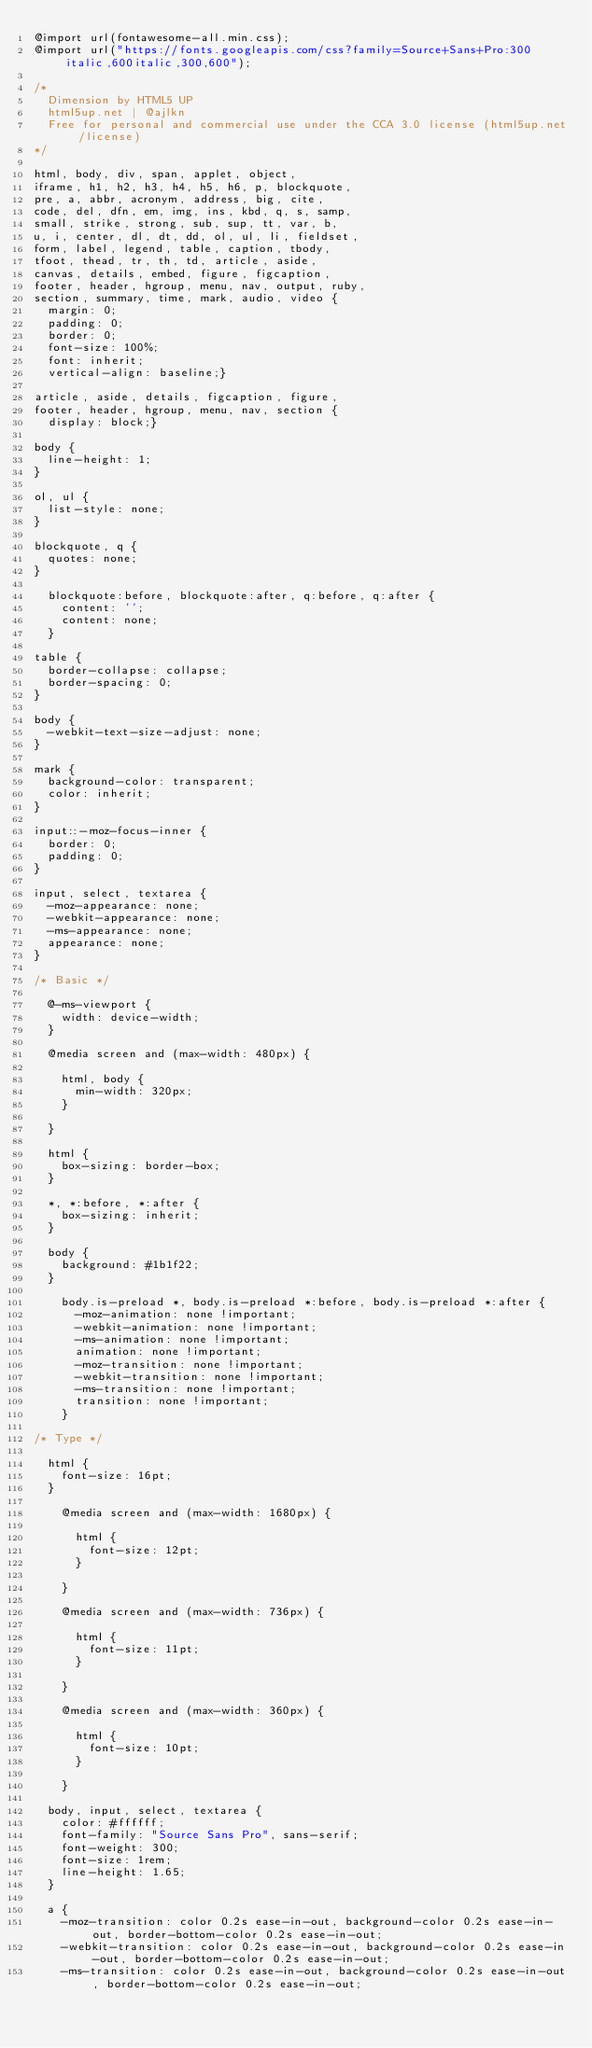Convert code to text. <code><loc_0><loc_0><loc_500><loc_500><_CSS_>@import url(fontawesome-all.min.css);
@import url("https://fonts.googleapis.com/css?family=Source+Sans+Pro:300italic,600italic,300,600");

/*
	Dimension by HTML5 UP
	html5up.net | @ajlkn
	Free for personal and commercial use under the CCA 3.0 license (html5up.net/license)
*/

html, body, div, span, applet, object,
iframe, h1, h2, h3, h4, h5, h6, p, blockquote,
pre, a, abbr, acronym, address, big, cite,
code, del, dfn, em, img, ins, kbd, q, s, samp,
small, strike, strong, sub, sup, tt, var, b,
u, i, center, dl, dt, dd, ol, ul, li, fieldset,
form, label, legend, table, caption, tbody,
tfoot, thead, tr, th, td, article, aside,
canvas, details, embed, figure, figcaption,
footer, header, hgroup, menu, nav, output, ruby,
section, summary, time, mark, audio, video {
	margin: 0;
	padding: 0;
	border: 0;
	font-size: 100%;
	font: inherit;
	vertical-align: baseline;}

article, aside, details, figcaption, figure,
footer, header, hgroup, menu, nav, section {
	display: block;}

body {
	line-height: 1;
}

ol, ul {
	list-style: none;
}

blockquote, q {
	quotes: none;
}

	blockquote:before, blockquote:after, q:before, q:after {
		content: '';
		content: none;
	}

table {
	border-collapse: collapse;
	border-spacing: 0;
}

body {
	-webkit-text-size-adjust: none;
}

mark {
	background-color: transparent;
	color: inherit;
}

input::-moz-focus-inner {
	border: 0;
	padding: 0;
}

input, select, textarea {
	-moz-appearance: none;
	-webkit-appearance: none;
	-ms-appearance: none;
	appearance: none;
}

/* Basic */

	@-ms-viewport {
		width: device-width;
	}

	@media screen and (max-width: 480px) {

		html, body {
			min-width: 320px;
		}

	}

	html {
		box-sizing: border-box;
	}

	*, *:before, *:after {
		box-sizing: inherit;
	}

	body {
		background: #1b1f22;
	}

		body.is-preload *, body.is-preload *:before, body.is-preload *:after {
			-moz-animation: none !important;
			-webkit-animation: none !important;
			-ms-animation: none !important;
			animation: none !important;
			-moz-transition: none !important;
			-webkit-transition: none !important;
			-ms-transition: none !important;
			transition: none !important;
		}

/* Type */

	html {
		font-size: 16pt;
	}

		@media screen and (max-width: 1680px) {

			html {
				font-size: 12pt;
			}

		}

		@media screen and (max-width: 736px) {

			html {
				font-size: 11pt;
			}

		}

		@media screen and (max-width: 360px) {

			html {
				font-size: 10pt;
			}

		}

	body, input, select, textarea {
		color: #ffffff;
		font-family: "Source Sans Pro", sans-serif;
		font-weight: 300;
		font-size: 1rem;
		line-height: 1.65;
	}

	a {
		-moz-transition: color 0.2s ease-in-out, background-color 0.2s ease-in-out, border-bottom-color 0.2s ease-in-out;
		-webkit-transition: color 0.2s ease-in-out, background-color 0.2s ease-in-out, border-bottom-color 0.2s ease-in-out;
		-ms-transition: color 0.2s ease-in-out, background-color 0.2s ease-in-out, border-bottom-color 0.2s ease-in-out;</code> 